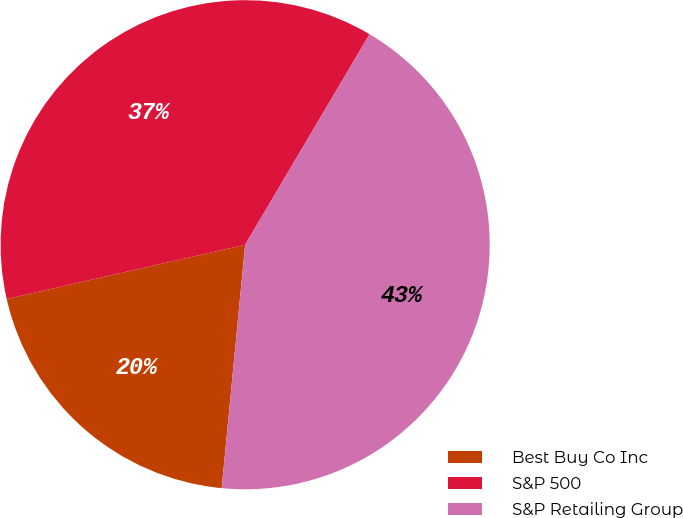<chart> <loc_0><loc_0><loc_500><loc_500><pie_chart><fcel>Best Buy Co Inc<fcel>S&P 500<fcel>S&P Retailing Group<nl><fcel>19.91%<fcel>37.06%<fcel>43.04%<nl></chart> 